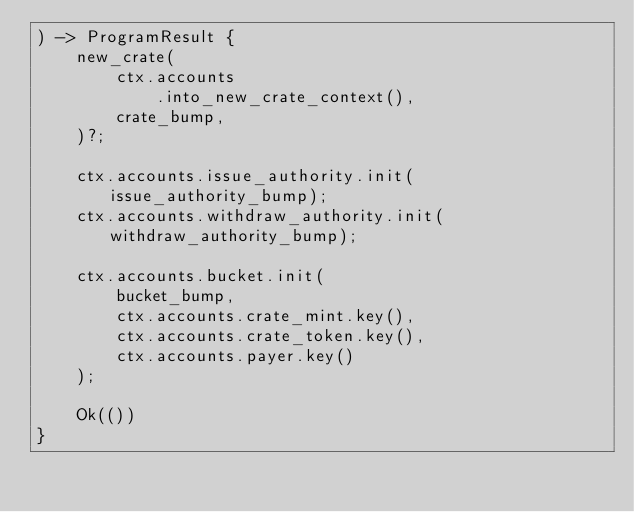Convert code to text. <code><loc_0><loc_0><loc_500><loc_500><_Rust_>) -> ProgramResult {
    new_crate(
        ctx.accounts
            .into_new_crate_context(),
        crate_bump,
    )?;

    ctx.accounts.issue_authority.init(issue_authority_bump);
    ctx.accounts.withdraw_authority.init(withdraw_authority_bump);

    ctx.accounts.bucket.init(
        bucket_bump,
        ctx.accounts.crate_mint.key(),
        ctx.accounts.crate_token.key(),
        ctx.accounts.payer.key()
    );

    Ok(())
}
</code> 